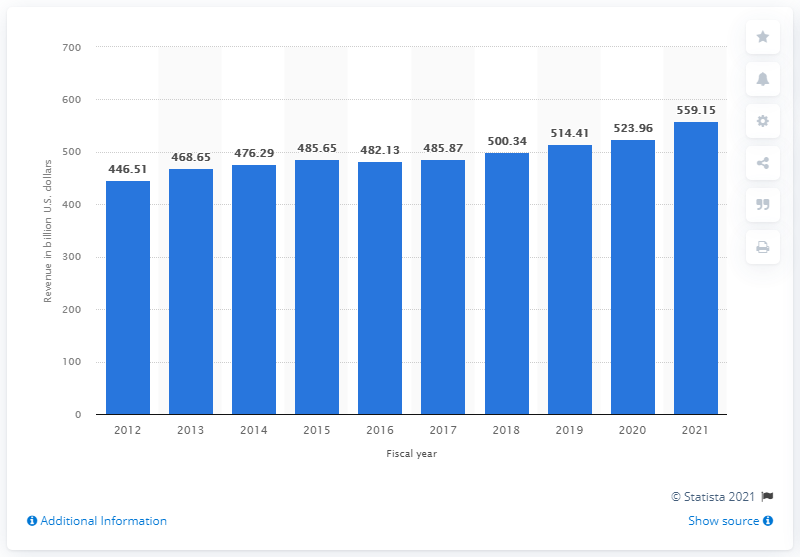Mention a couple of crucial points in this snapshot. Walmart's revenue in 2021 was 559.15 billion dollars. Walmart's fiscal year ended in 2021. Walmart's revenue increased by 559.15% compared to the previous year. Walmart operates a variety of stores that cater to the needs of its customers, including supercenters, discount stores, and Neighborhood Markets. These stores offer a wide range of products at affordable prices to meet the demands of customers from different backgrounds and lifestyles. 